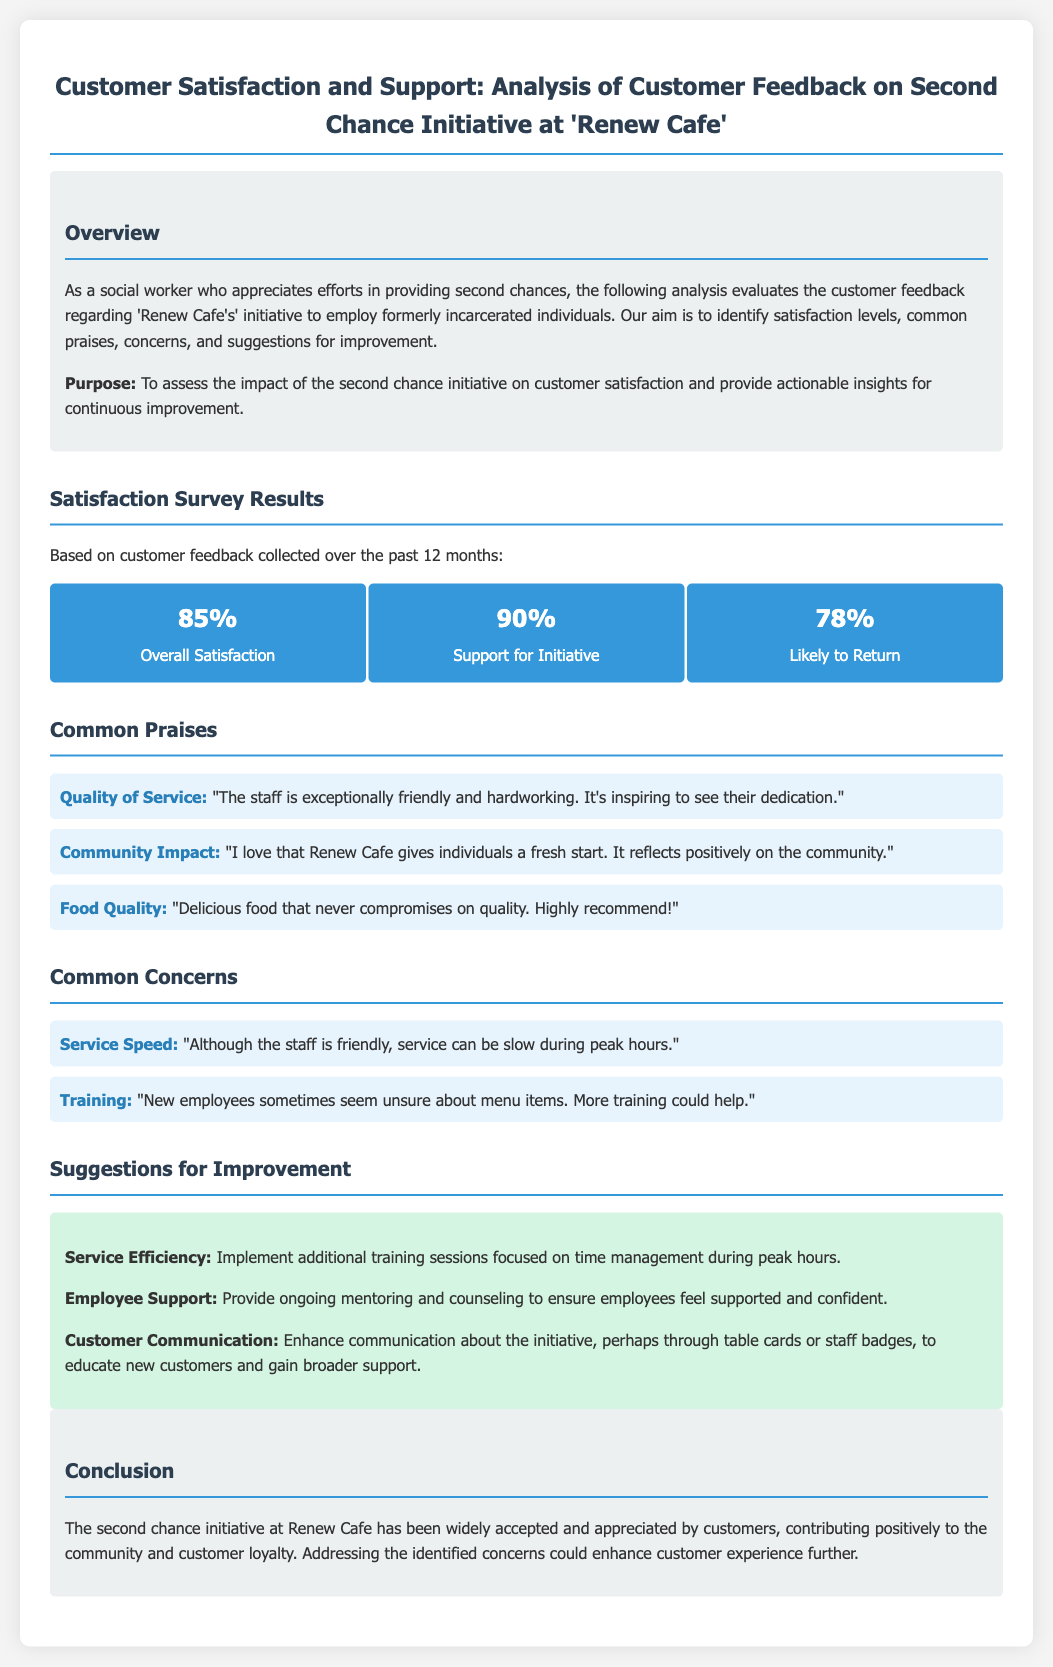what is the overall satisfaction percentage? The overall satisfaction is indicated as 85% in the satisfaction survey results.
Answer: 85% what percentage of customers support the initiative? The document states that 90% of customers support the initiative.
Answer: 90% what is mentioned as a common praise regarding the quality of service? Customers praise the friendly and hardworking staff as a common aspect in the feedback.
Answer: "The staff is exceptionally friendly and hardworking." what concern is raised regarding service speed? The feedback points out that service can be slow during peak hours.
Answer: "Service can be slow during peak hours." what suggestion is made for improving employee support? The document suggests providing ongoing mentoring and counseling for employee support.
Answer: "Provide ongoing mentoring and counseling." what aspect does the conclusion emphasize about the second chance initiative? The conclusion emphasizes that the initiative has been widely accepted and appreciated by customers.
Answer: "Widely accepted and appreciated by customers." how many metrics are presented in the satisfaction survey results? Three metrics are presented in the satisfaction survey results.
Answer: Three what is the main purpose of this scorecard? The purpose is to assess the impact of the initiative on customer satisfaction.
Answer: To assess the impact of the second chance initiative on customer satisfaction 